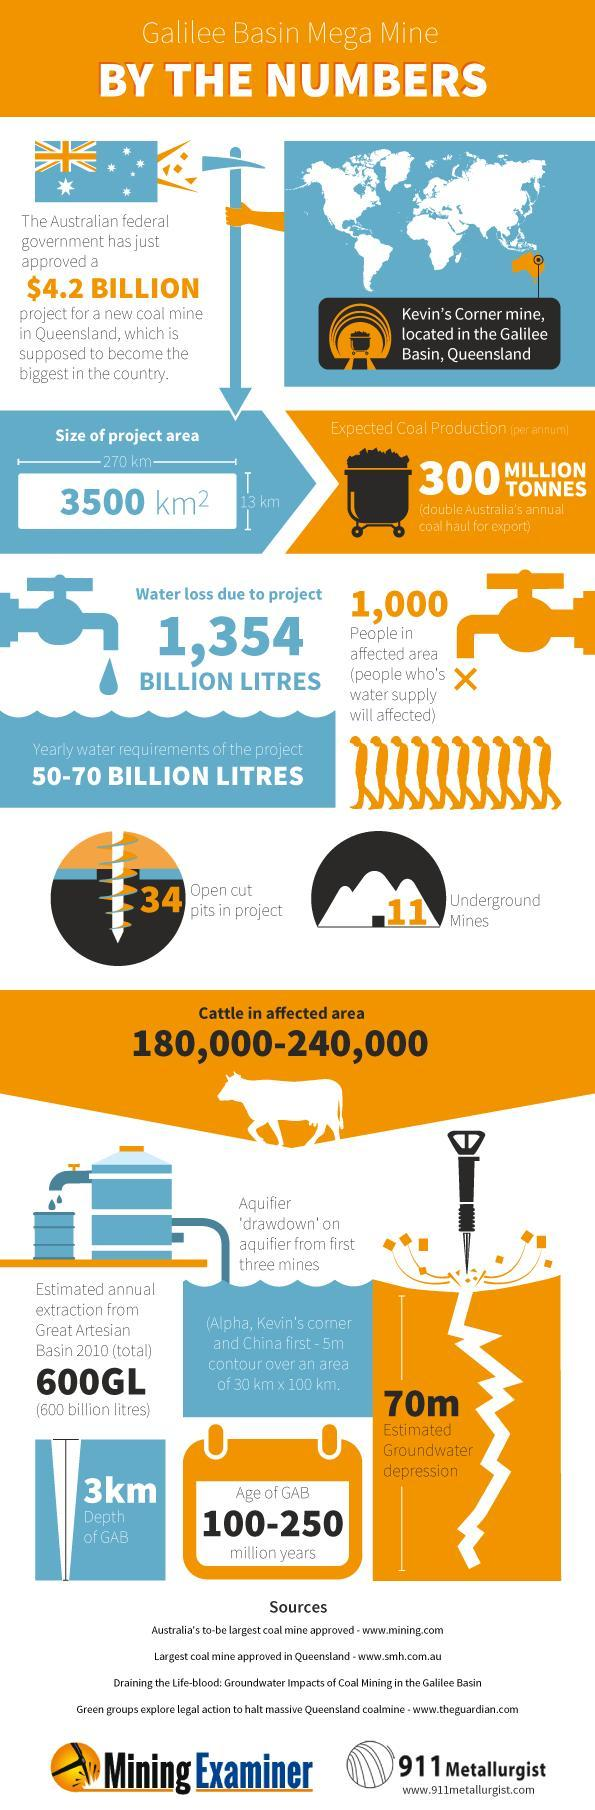How many men's picture is shown in the infographics, 10 or 9?
Answer the question with a short phrase. 9 What is the breadth of the project area? 13 km What is the expected water loss due to the new coal mine project in Queensland? 1,354 BILLION LITRES Which animal's picture is shown in the infographics? Cattle What is the area of the new coal mine in Queensland? 3500 km2 What is the length of the project area? 270 km 